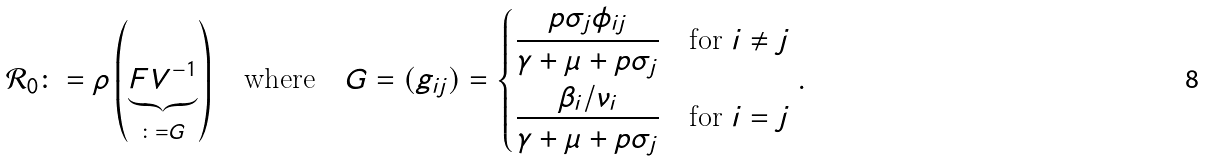<formula> <loc_0><loc_0><loc_500><loc_500>\mathcal { R } _ { 0 } \colon = \rho \left ( \underbrace { F V ^ { - 1 } } _ { \colon = G } \right ) \quad \text {where} \quad G = ( g _ { i j } ) = \begin{dcases} \frac { p \sigma _ { j } \phi _ { i j } } { \gamma + \mu + p \sigma _ { j } } & \text {for } i \neq j \\ \frac { \beta _ { i } \slash \nu _ { i } } { \gamma + \mu + p \sigma _ { j } } & \text {for } i = j \end{dcases} .</formula> 